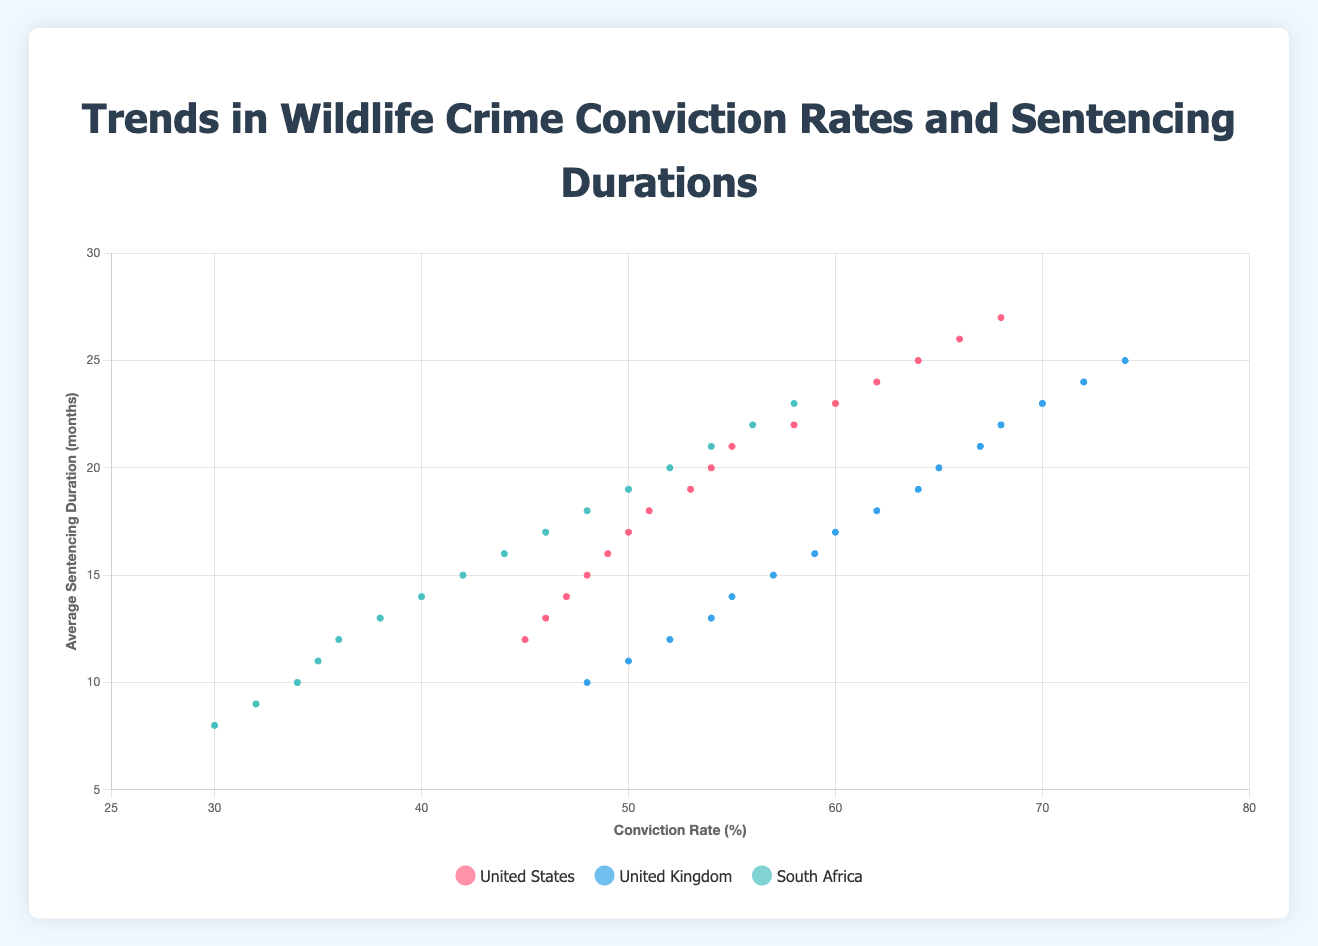What is the average conviction rate of the United States, United Kingdom, and South Africa in 2023? First, find the conviction rates for each country in 2023: United States (68%), United Kingdom (74%), and South Africa (58%). Then, calculate the average: (68 + 74 + 58) / 3 = 200 / 3 ≈ 66.67
Answer: 66.67 Compare the conviction rates between the United States and the United Kingdom in 2020. Which country had a higher rate, and by how much? The conviction rate for the United States in 2020 is 62% and for the United Kingdom is 68%. The difference is 68 - 62 = 6%. The United Kingdom had a higher rate by 6%.
Answer: United Kingdom by 6% Which country had the most significant increase in average sentencing duration from 2008 to 2023? Find the average sentencing duration for 2008 and 2023 for each country: United States (12 to 27), United Kingdom (10 to 25), and South Africa (8 to 23). Calculate the increases: United States (27 - 12 = 15), United Kingdom (25 - 10 = 15), South Africa (23 - 8 = 15). All three countries had the same increase of 15 months.
Answer: All three countries In which year did South Africa first achieve an average sentencing duration of 20 months or more? Look for the first instance in the data where South Africa's average sentencing duration reached 20 months or more. According to the plot, this happened in 2020.
Answer: 2020 How many years did it take for the conviction rate in the United Kingdom to increase from 50% to 70%? Identify the years in which these rates were recorded: 50% in 2009 and 70% in 2021. The number of years between 2009 and 2021 is 2021 - 2009 = 12 years.
Answer: 12 years Which year had the highest overall conviction rate among all countries? Compare the conviction rates for all countries across all years. The highest rate is the United Kingdom in 2023 with a rate of 74%.
Answer: 2023 What color line represents the United Kingdom in the chart? Referring to the visual attribute of color in the plot, the line for the United Kingdom is blue.
Answer: Blue By how much did the average sentencing duration in the United States change from 2008 to 2016? Calculate the difference between the average sentencing durations for the United States in 2008 (12 months) and 2016 (20 months): 20 - 12 = 8 months.
Answer: 8 months 